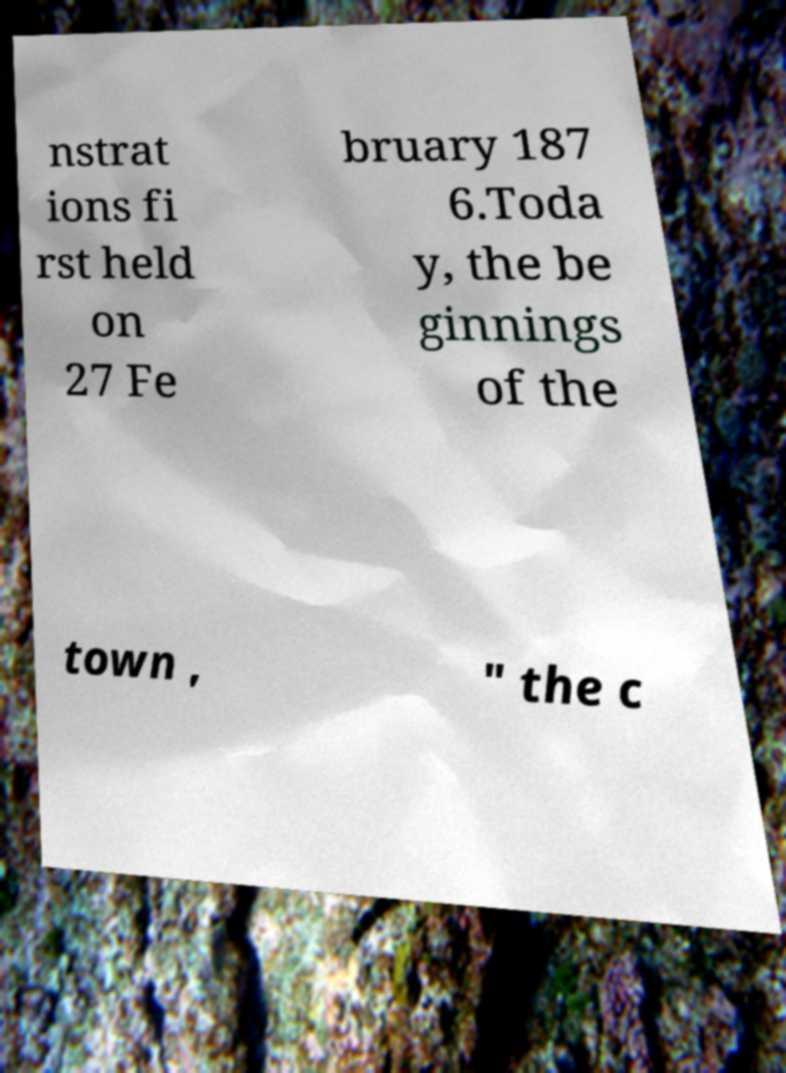I need the written content from this picture converted into text. Can you do that? nstrat ions fi rst held on 27 Fe bruary 187 6.Toda y, the be ginnings of the town , " the c 